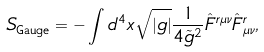<formula> <loc_0><loc_0><loc_500><loc_500>S _ { \text {Gauge} } = - \int d ^ { 4 } x \sqrt { | g | } \frac { 1 } { 4 \tilde { g } ^ { 2 } } \hat { F } ^ { r \mu \nu } \hat { F } _ { \mu \nu } ^ { r } ,</formula> 